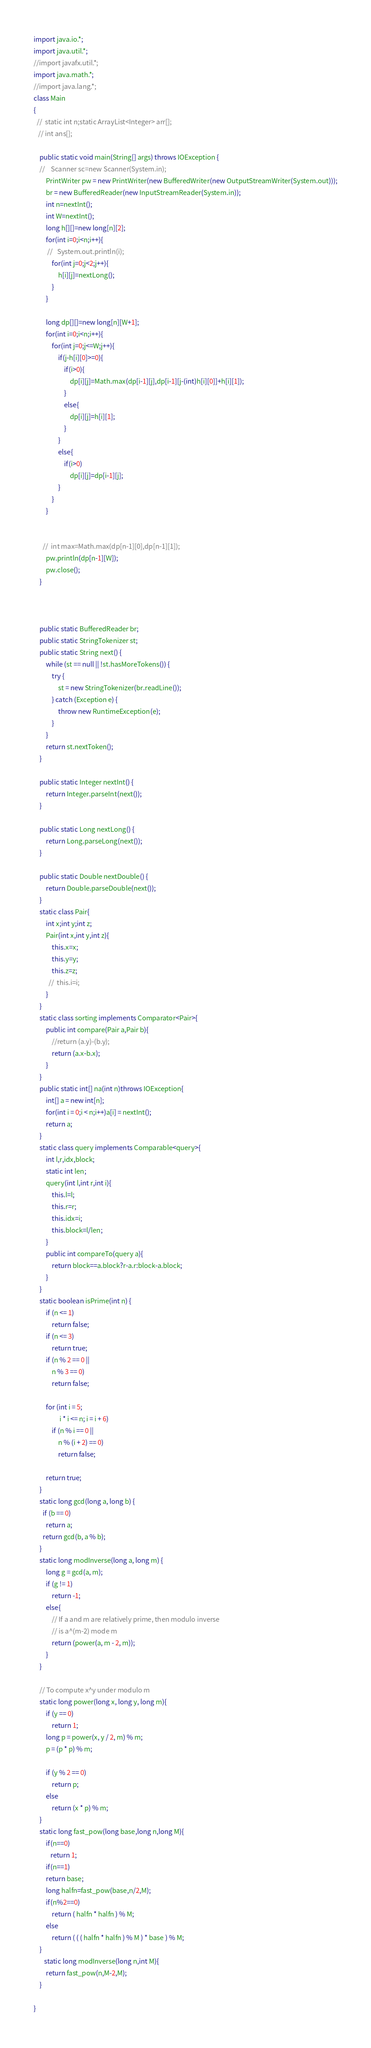Convert code to text. <code><loc_0><loc_0><loc_500><loc_500><_Java_>import java.io.*; 
import java.util.*; 
//import javafx.util.*; 
import java.math.*;
//import java.lang.*;
class Main 
{ 
  //  static int n;static ArrayList<Integer> arr[];
   // int ans[];
   
    public static void main(String[] args) throws IOException { 
    //    Scanner sc=new Scanner(System.in);
        PrintWriter pw = new PrintWriter(new BufferedWriter(new OutputStreamWriter(System.out)));
        br = new BufferedReader(new InputStreamReader(System.in));
        int n=nextInt();
        int W=nextInt();
        long h[][]=new long[n][2];
        for(int i=0;i<n;i++){
         //   System.out.println(i); 
            for(int j=0;j<2;j++){
                h[i][j]=nextLong();
            }
        }
        
        long dp[][]=new long[n][W+1];
        for(int i=0;i<n;i++){
            for(int j=0;j<=W;j++){
                if(j-h[i][0]>=0){
                    if(i>0){
                        dp[i][j]=Math.max(dp[i-1][j],dp[i-1][j-(int)h[i][0]]+h[i][1]);
                    }
                    else{
                        dp[i][j]=h[i][1];
                    }
                }
                else{
                    if(i>0)
                        dp[i][j]=dp[i-1][j];
                }
            }
        }
        
        
      //  int max=Math.max(dp[n-1][0],dp[n-1][1]);
        pw.println(dp[n-1][W]);
        pw.close();
    }
   

    
    public static BufferedReader br;
    public static StringTokenizer st;
    public static String next() {
        while (st == null || !st.hasMoreTokens()) {
            try {
                st = new StringTokenizer(br.readLine());
            } catch (Exception e) {
                throw new RuntimeException(e);
            }
        }
        return st.nextToken();
    }
 
    public static Integer nextInt() {
        return Integer.parseInt(next());
    }
 
    public static Long nextLong() {
        return Long.parseLong(next());
    }
 
    public static Double nextDouble() {
        return Double.parseDouble(next());
    }
    static class Pair{
        int x;int y;int z;
        Pair(int x,int y,int z){
            this.x=x;
            this.y=y;
            this.z=z;
          //  this.i=i;
        }
    }
    static class sorting implements Comparator<Pair>{
        public int compare(Pair a,Pair b){
            //return (a.y)-(b.y);
            return (a.x-b.x);
        }
    }
    public static int[] na(int n)throws IOException{
        int[] a = new int[n];
        for(int i = 0;i < n;i++)a[i] = nextInt();
        return a;
    }
    static class query implements Comparable<query>{
        int l,r,idx,block;
        static int len;
        query(int l,int r,int i){
            this.l=l;
            this.r=r;
            this.idx=i;
            this.block=l/len;
        }   
        public int compareTo(query a){
            return block==a.block?r-a.r:block-a.block;
        }
    }
    static boolean isPrime(int n) { 
        if (n <= 1) 
            return false; 
        if (n <= 3) 
            return true; 
        if (n % 2 == 0 ||  
            n % 3 == 0) 
            return false; 
      
        for (int i = 5; 
                 i * i <= n; i = i + 6) 
            if (n % i == 0 || 
                n % (i + 2) == 0) 
                return false; 
      
        return true; 
    } 
    static long gcd(long a, long b) { 
      if (b == 0) 
        return a; 
      return gcd(b, a % b);  
    }  
    static long modInverse(long a, long m) { 
        long g = gcd(a, m); 
        if (g != 1) 
            return -1; 
        else{ 
            // If a and m are relatively prime, then modulo inverse 
            // is a^(m-2) mode m 
            return (power(a, m - 2, m)); 
        } 
    } 
      
    // To compute x^y under modulo m 
    static long power(long x, long y, long m){ 
        if (y == 0) 
            return 1;      
        long p = power(x, y / 2, m) % m; 
        p = (p * p) % m; 
      
        if (y % 2 == 0) 
            return p; 
        else
            return (x * p) % m; 
    }
    static long fast_pow(long base,long n,long M){
        if(n==0)
           return 1;
        if(n==1)
        return base;
        long halfn=fast_pow(base,n/2,M);
        if(n%2==0)
            return ( halfn * halfn ) % M;
        else
            return ( ( ( halfn * halfn ) % M ) * base ) % M;
    }
       static long modInverse(long n,int M){
        return fast_pow(n,M-2,M);
    }
    
} </code> 